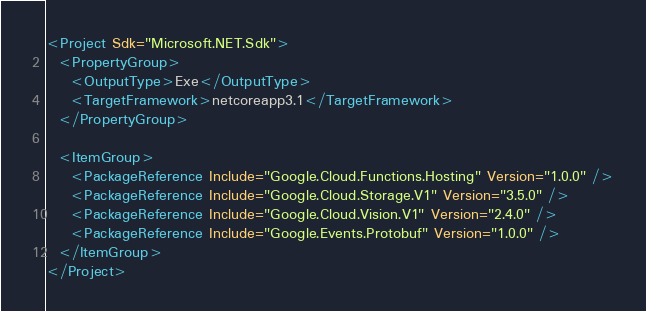Convert code to text. <code><loc_0><loc_0><loc_500><loc_500><_XML_><Project Sdk="Microsoft.NET.Sdk">
  <PropertyGroup>
    <OutputType>Exe</OutputType>
    <TargetFramework>netcoreapp3.1</TargetFramework>
  </PropertyGroup>

  <ItemGroup>
    <PackageReference Include="Google.Cloud.Functions.Hosting" Version="1.0.0" />
    <PackageReference Include="Google.Cloud.Storage.V1" Version="3.5.0" />
    <PackageReference Include="Google.Cloud.Vision.V1" Version="2.4.0" />
    <PackageReference Include="Google.Events.Protobuf" Version="1.0.0" />
  </ItemGroup>
</Project>
</code> 